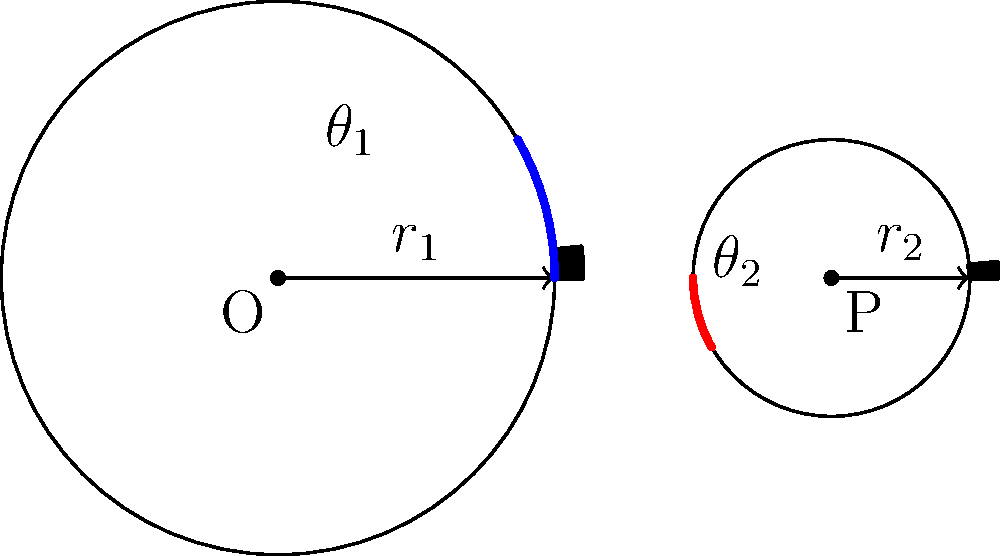In a traditional mechanical clock, two interlocking gears are shown above. The larger gear, centered at O, has a radius $r_1 = 2$ inches and 12 teeth. The smaller gear, centered at P, has a radius $r_2 = 1$ inch and 6 teeth. When the larger gear rotates through an angle $\theta_1 = 30°$, what is the corresponding angle $\theta_2$ through which the smaller gear rotates? Express your answer in degrees. Let's approach this problem using the principles of gear mechanics and congruence:

1) In interlocking gears, the arc length traveled by both gears at their point of contact must be equal. This ensures smooth rotation without slipping.

2) Arc length is given by the formula: $s = r\theta$, where $s$ is the arc length, $r$ is the radius, and $\theta$ is the angle in radians.

3) For the larger gear:
   $s_1 = r_1\theta_1 = 2 \cdot \frac{30\pi}{180} = \frac{\pi}{3}$ inches

4) This arc length must be equal for the smaller gear:
   $s_2 = s_1 = \frac{\pi}{3}$ inches

5) Now we can find $\theta_2$ using the arc length formula for the smaller gear:
   $\frac{\pi}{3} = r_2\theta_2 = 1 \cdot \theta_2$

6) Solving for $\theta_2$:
   $\theta_2 = \frac{\pi}{3}$ radians

7) Converting back to degrees:
   $\theta_2 = \frac{\pi}{3} \cdot \frac{180}{\pi} = 60°$

8) We can verify this result by considering the ratio of teeth:
   $\frac{\text{Teeth on larger gear}}{\text{Teeth on smaller gear}} = \frac{12}{6} = 2$
   This means the smaller gear should rotate twice as much as the larger gear, which our calculation confirms.
Answer: 60° 